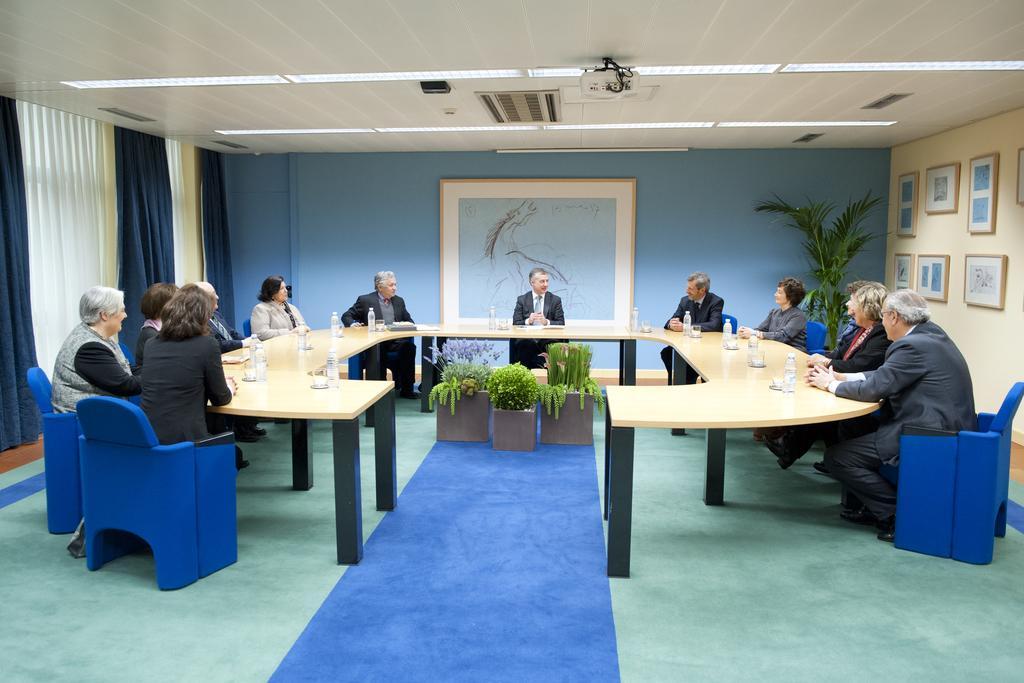How would you summarize this image in a sentence or two? The group of people sitting in chairs and there is a table in front of them which has water bottles on it and the background wall is blue in color. 